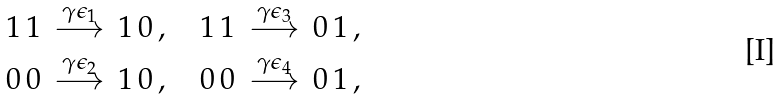Convert formula to latex. <formula><loc_0><loc_0><loc_500><loc_500>1 \, 1 \, \stackrel { \gamma \epsilon _ { 1 } } { \longrightarrow } \, 1 \, 0 \, , \quad 1 \, 1 \, \stackrel { \gamma \epsilon _ { 3 } } { \longrightarrow } \, 0 \, 1 \, , \\ 0 \, 0 \, \stackrel { \gamma \epsilon _ { 2 } } { \longrightarrow } \, 1 \, 0 \, , \quad 0 \, 0 \, \stackrel { \gamma \epsilon _ { 4 } } { \longrightarrow } \, 0 \, 1 \, ,</formula> 